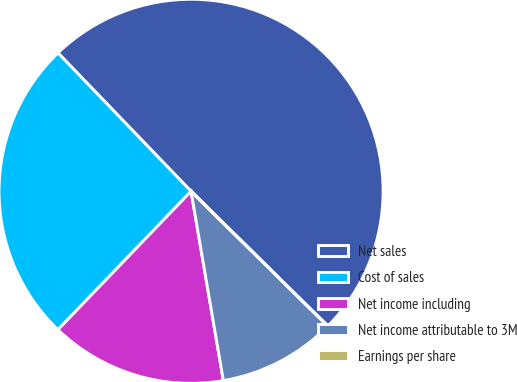<chart> <loc_0><loc_0><loc_500><loc_500><pie_chart><fcel>Net sales<fcel>Cost of sales<fcel>Net income including<fcel>Net income attributable to 3M<fcel>Earnings per share<nl><fcel>49.57%<fcel>25.62%<fcel>14.88%<fcel>9.92%<fcel>0.01%<nl></chart> 